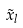<formula> <loc_0><loc_0><loc_500><loc_500>\vec { x } _ { l }</formula> 